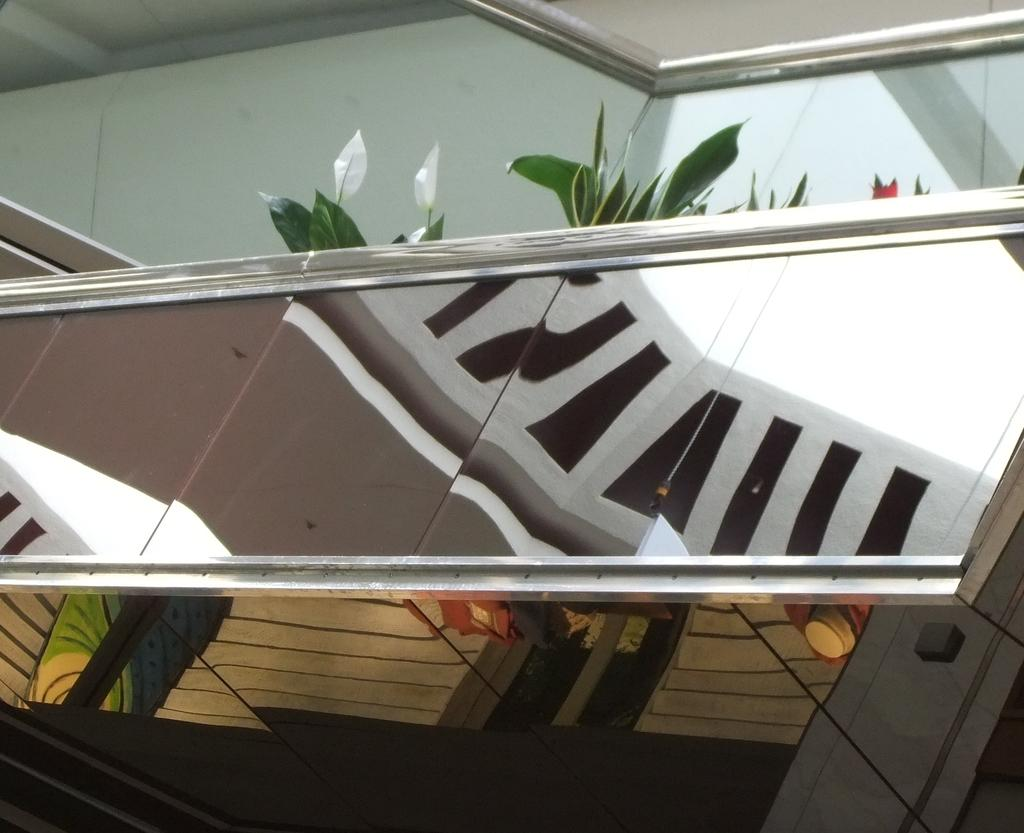What type of living organisms can be seen in the image? Plants can be seen in the image. What is the source of illumination in the image? There is a light source in the image. What type of architectural feature is present in the image? There is a wall in the image. What is the purpose of the mirror board in the image? The mirror board is likely used for reflecting light or creating a specific visual effect. What can be seen through the window in the image? The contents of the scene outside the window are not visible in the image. What type of tooth is visible in the image? There is no tooth present in the image. What type of berry can be seen growing on the plants in the image? The type of berry cannot be determined from the image, as the plants are not identified. 